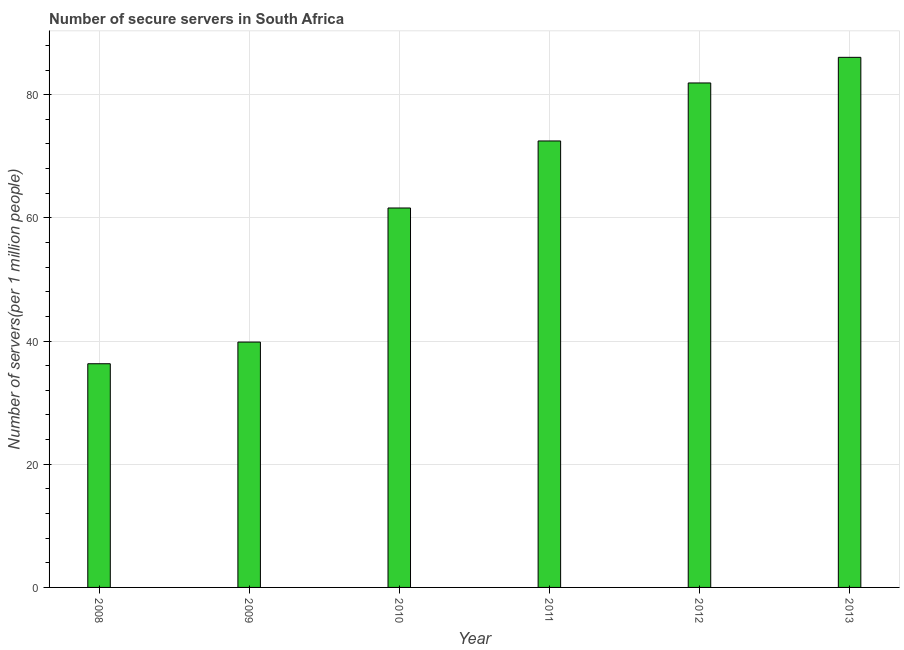What is the title of the graph?
Your answer should be compact. Number of secure servers in South Africa. What is the label or title of the X-axis?
Keep it short and to the point. Year. What is the label or title of the Y-axis?
Offer a very short reply. Number of servers(per 1 million people). What is the number of secure internet servers in 2010?
Give a very brief answer. 61.6. Across all years, what is the maximum number of secure internet servers?
Your answer should be compact. 86.07. Across all years, what is the minimum number of secure internet servers?
Your answer should be very brief. 36.32. In which year was the number of secure internet servers minimum?
Give a very brief answer. 2008. What is the sum of the number of secure internet servers?
Keep it short and to the point. 378.21. What is the difference between the number of secure internet servers in 2008 and 2013?
Offer a very short reply. -49.75. What is the average number of secure internet servers per year?
Your response must be concise. 63.04. What is the median number of secure internet servers?
Provide a succinct answer. 67.05. Do a majority of the years between 2009 and 2012 (inclusive) have number of secure internet servers greater than 76 ?
Your response must be concise. No. What is the ratio of the number of secure internet servers in 2008 to that in 2011?
Offer a terse response. 0.5. Is the difference between the number of secure internet servers in 2008 and 2013 greater than the difference between any two years?
Provide a succinct answer. Yes. What is the difference between the highest and the second highest number of secure internet servers?
Provide a succinct answer. 4.16. Is the sum of the number of secure internet servers in 2008 and 2009 greater than the maximum number of secure internet servers across all years?
Ensure brevity in your answer.  No. What is the difference between the highest and the lowest number of secure internet servers?
Offer a very short reply. 49.75. How many bars are there?
Offer a terse response. 6. Are all the bars in the graph horizontal?
Offer a very short reply. No. How many years are there in the graph?
Your answer should be very brief. 6. What is the Number of servers(per 1 million people) in 2008?
Offer a terse response. 36.32. What is the Number of servers(per 1 million people) of 2009?
Provide a short and direct response. 39.84. What is the Number of servers(per 1 million people) in 2010?
Your answer should be very brief. 61.6. What is the Number of servers(per 1 million people) of 2011?
Your answer should be very brief. 72.49. What is the Number of servers(per 1 million people) in 2012?
Offer a very short reply. 81.9. What is the Number of servers(per 1 million people) in 2013?
Make the answer very short. 86.07. What is the difference between the Number of servers(per 1 million people) in 2008 and 2009?
Your answer should be very brief. -3.52. What is the difference between the Number of servers(per 1 million people) in 2008 and 2010?
Ensure brevity in your answer.  -25.29. What is the difference between the Number of servers(per 1 million people) in 2008 and 2011?
Your response must be concise. -36.17. What is the difference between the Number of servers(per 1 million people) in 2008 and 2012?
Your answer should be compact. -45.59. What is the difference between the Number of servers(per 1 million people) in 2008 and 2013?
Ensure brevity in your answer.  -49.75. What is the difference between the Number of servers(per 1 million people) in 2009 and 2010?
Provide a short and direct response. -21.77. What is the difference between the Number of servers(per 1 million people) in 2009 and 2011?
Your answer should be very brief. -32.65. What is the difference between the Number of servers(per 1 million people) in 2009 and 2012?
Provide a succinct answer. -42.07. What is the difference between the Number of servers(per 1 million people) in 2009 and 2013?
Keep it short and to the point. -46.23. What is the difference between the Number of servers(per 1 million people) in 2010 and 2011?
Ensure brevity in your answer.  -10.88. What is the difference between the Number of servers(per 1 million people) in 2010 and 2012?
Your answer should be very brief. -20.3. What is the difference between the Number of servers(per 1 million people) in 2010 and 2013?
Offer a terse response. -24.46. What is the difference between the Number of servers(per 1 million people) in 2011 and 2012?
Offer a very short reply. -9.42. What is the difference between the Number of servers(per 1 million people) in 2011 and 2013?
Make the answer very short. -13.58. What is the difference between the Number of servers(per 1 million people) in 2012 and 2013?
Offer a very short reply. -4.16. What is the ratio of the Number of servers(per 1 million people) in 2008 to that in 2009?
Your response must be concise. 0.91. What is the ratio of the Number of servers(per 1 million people) in 2008 to that in 2010?
Provide a succinct answer. 0.59. What is the ratio of the Number of servers(per 1 million people) in 2008 to that in 2011?
Provide a short and direct response. 0.5. What is the ratio of the Number of servers(per 1 million people) in 2008 to that in 2012?
Give a very brief answer. 0.44. What is the ratio of the Number of servers(per 1 million people) in 2008 to that in 2013?
Make the answer very short. 0.42. What is the ratio of the Number of servers(per 1 million people) in 2009 to that in 2010?
Make the answer very short. 0.65. What is the ratio of the Number of servers(per 1 million people) in 2009 to that in 2011?
Offer a very short reply. 0.55. What is the ratio of the Number of servers(per 1 million people) in 2009 to that in 2012?
Give a very brief answer. 0.49. What is the ratio of the Number of servers(per 1 million people) in 2009 to that in 2013?
Offer a very short reply. 0.46. What is the ratio of the Number of servers(per 1 million people) in 2010 to that in 2011?
Keep it short and to the point. 0.85. What is the ratio of the Number of servers(per 1 million people) in 2010 to that in 2012?
Your answer should be very brief. 0.75. What is the ratio of the Number of servers(per 1 million people) in 2010 to that in 2013?
Your response must be concise. 0.72. What is the ratio of the Number of servers(per 1 million people) in 2011 to that in 2012?
Give a very brief answer. 0.89. What is the ratio of the Number of servers(per 1 million people) in 2011 to that in 2013?
Your response must be concise. 0.84. 